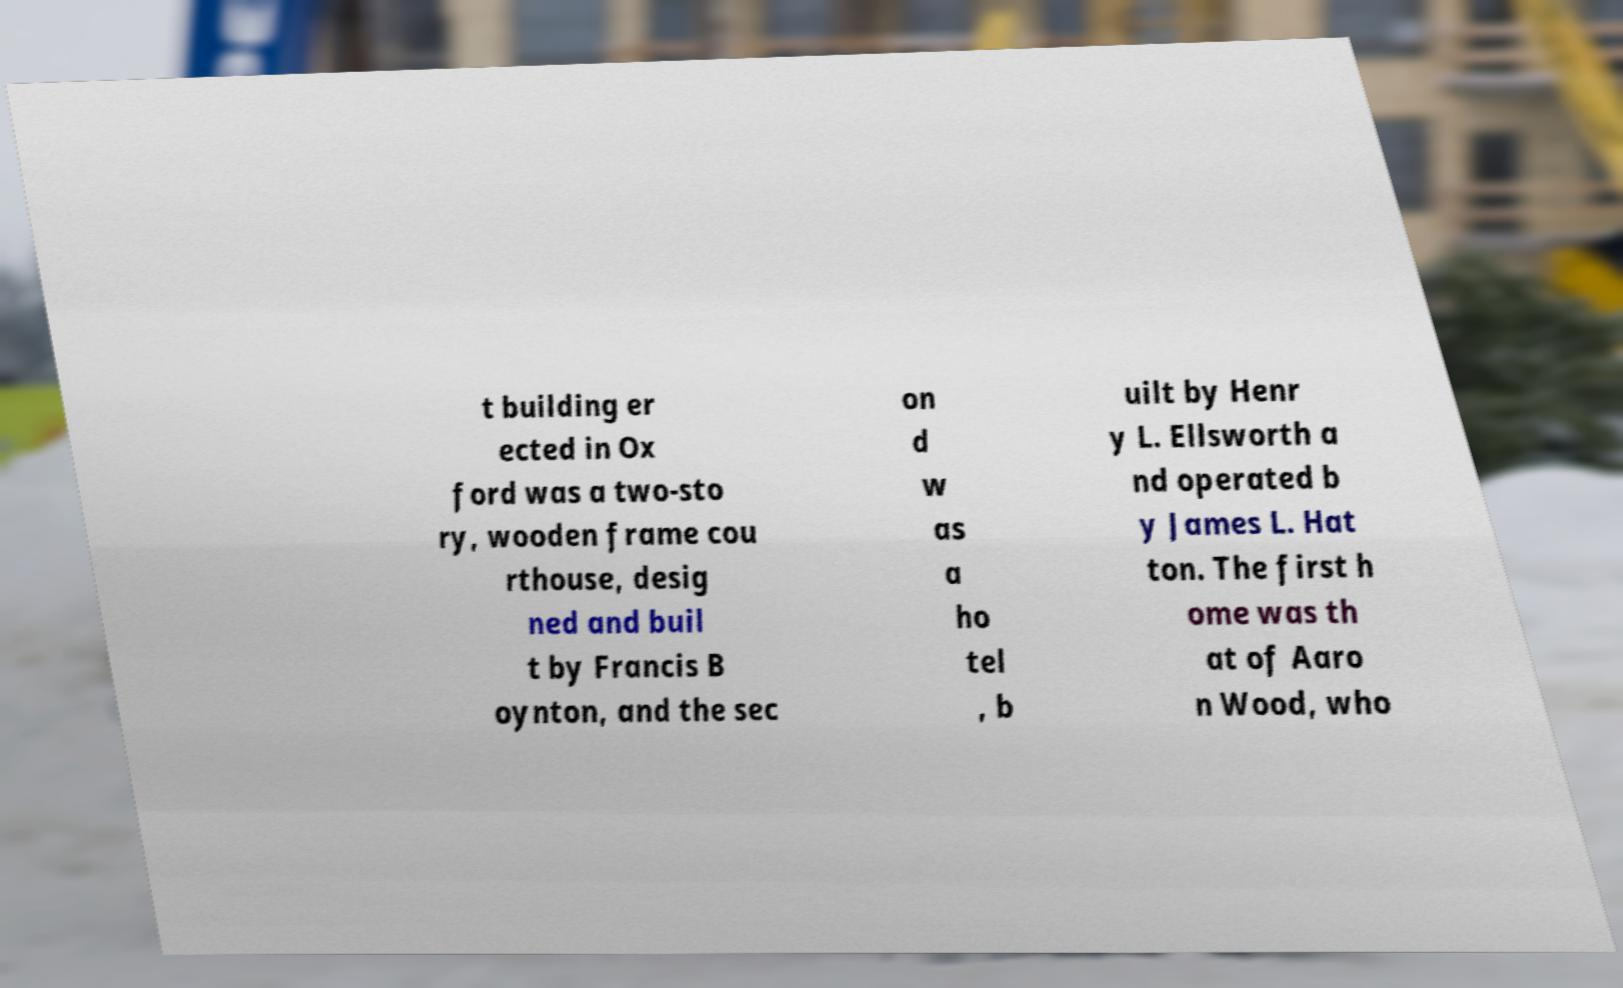Please read and relay the text visible in this image. What does it say? t building er ected in Ox ford was a two-sto ry, wooden frame cou rthouse, desig ned and buil t by Francis B oynton, and the sec on d w as a ho tel , b uilt by Henr y L. Ellsworth a nd operated b y James L. Hat ton. The first h ome was th at of Aaro n Wood, who 